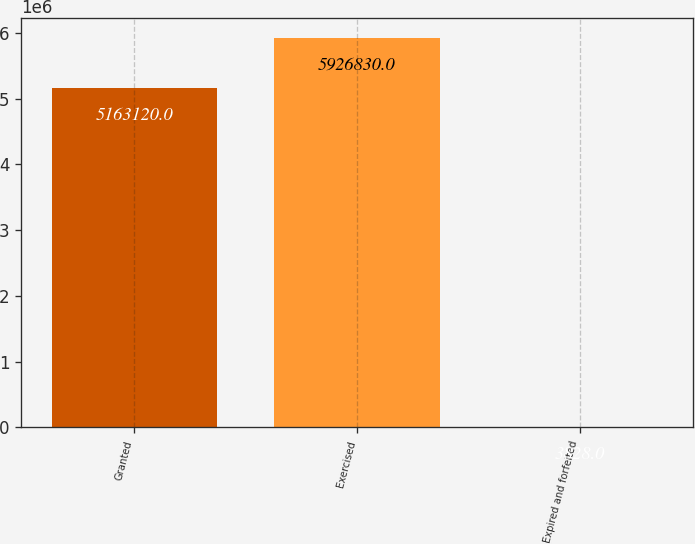<chart> <loc_0><loc_0><loc_500><loc_500><bar_chart><fcel>Granted<fcel>Exercised<fcel>Expired and forfeited<nl><fcel>5.16312e+06<fcel>5.92683e+06<fcel>3828<nl></chart> 